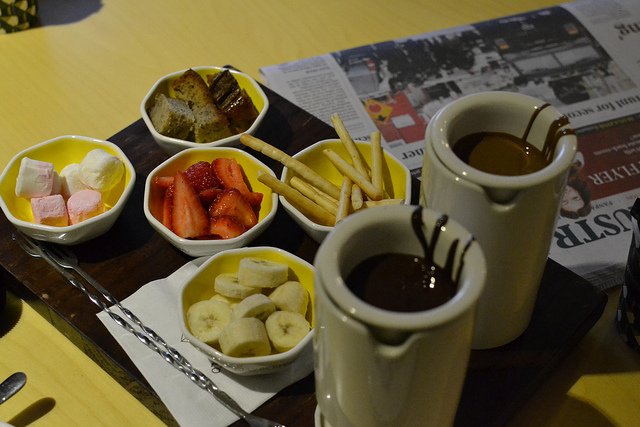Identify and read out the text in this image. for sec FLYER USTR 